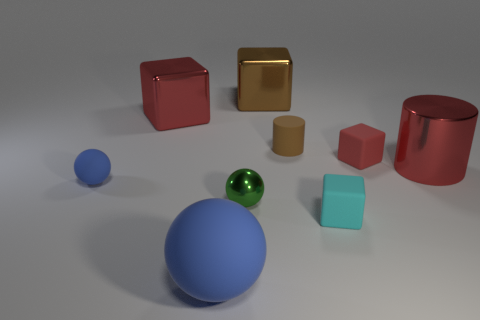Subtract all small cyan matte cubes. How many cubes are left? 3 Subtract all yellow cylinders. How many purple cubes are left? 0 Subtract all green shiny things. Subtract all brown cylinders. How many objects are left? 7 Add 7 large brown shiny blocks. How many large brown shiny blocks are left? 8 Add 3 brown matte things. How many brown matte things exist? 4 Add 1 tiny yellow rubber cylinders. How many objects exist? 10 Subtract all green balls. How many balls are left? 2 Subtract 0 blue blocks. How many objects are left? 9 Subtract all cubes. How many objects are left? 5 Subtract 2 spheres. How many spheres are left? 1 